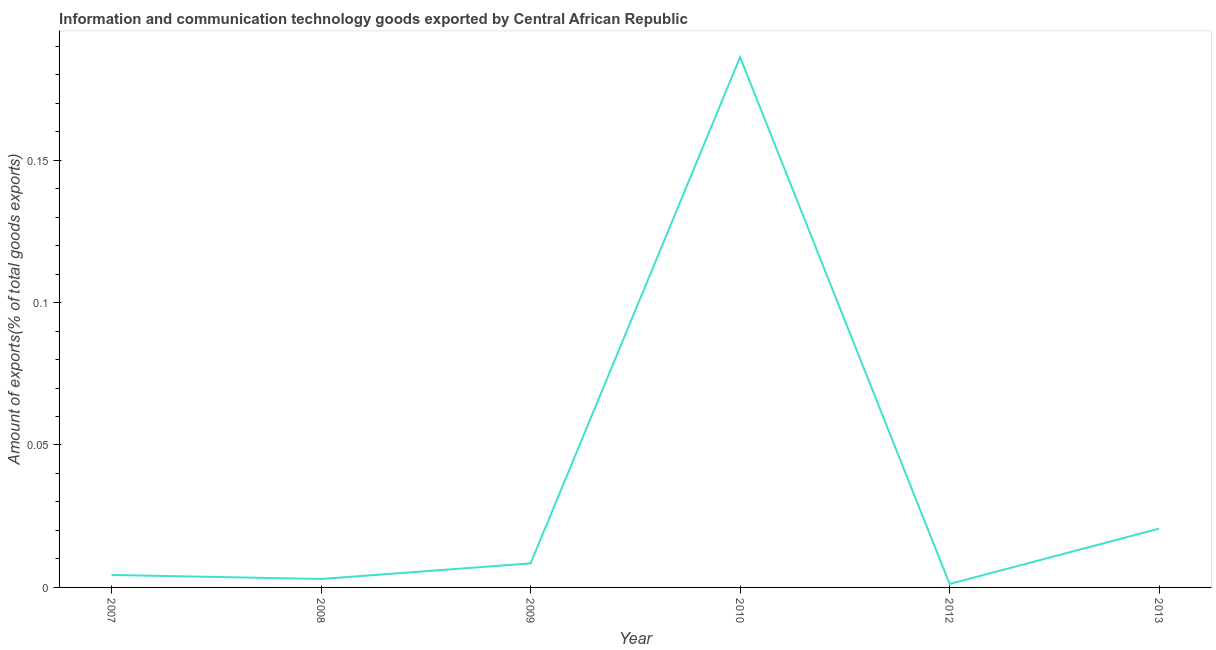What is the amount of ict goods exports in 2010?
Offer a very short reply. 0.19. Across all years, what is the maximum amount of ict goods exports?
Ensure brevity in your answer.  0.19. Across all years, what is the minimum amount of ict goods exports?
Ensure brevity in your answer.  0. In which year was the amount of ict goods exports maximum?
Give a very brief answer. 2010. In which year was the amount of ict goods exports minimum?
Make the answer very short. 2012. What is the sum of the amount of ict goods exports?
Provide a short and direct response. 0.22. What is the difference between the amount of ict goods exports in 2007 and 2008?
Your answer should be very brief. 0. What is the average amount of ict goods exports per year?
Provide a succinct answer. 0.04. What is the median amount of ict goods exports?
Give a very brief answer. 0.01. What is the ratio of the amount of ict goods exports in 2008 to that in 2013?
Ensure brevity in your answer.  0.14. Is the amount of ict goods exports in 2009 less than that in 2010?
Offer a very short reply. Yes. What is the difference between the highest and the second highest amount of ict goods exports?
Your response must be concise. 0.17. What is the difference between the highest and the lowest amount of ict goods exports?
Offer a very short reply. 0.18. In how many years, is the amount of ict goods exports greater than the average amount of ict goods exports taken over all years?
Provide a short and direct response. 1. How many lines are there?
Give a very brief answer. 1. What is the difference between two consecutive major ticks on the Y-axis?
Make the answer very short. 0.05. Are the values on the major ticks of Y-axis written in scientific E-notation?
Your answer should be very brief. No. Does the graph contain grids?
Your answer should be very brief. No. What is the title of the graph?
Provide a succinct answer. Information and communication technology goods exported by Central African Republic. What is the label or title of the X-axis?
Provide a succinct answer. Year. What is the label or title of the Y-axis?
Ensure brevity in your answer.  Amount of exports(% of total goods exports). What is the Amount of exports(% of total goods exports) of 2007?
Your answer should be compact. 0. What is the Amount of exports(% of total goods exports) of 2008?
Keep it short and to the point. 0. What is the Amount of exports(% of total goods exports) in 2009?
Ensure brevity in your answer.  0.01. What is the Amount of exports(% of total goods exports) in 2010?
Provide a succinct answer. 0.19. What is the Amount of exports(% of total goods exports) of 2012?
Keep it short and to the point. 0. What is the Amount of exports(% of total goods exports) in 2013?
Provide a succinct answer. 0.02. What is the difference between the Amount of exports(% of total goods exports) in 2007 and 2008?
Make the answer very short. 0. What is the difference between the Amount of exports(% of total goods exports) in 2007 and 2009?
Your response must be concise. -0. What is the difference between the Amount of exports(% of total goods exports) in 2007 and 2010?
Offer a very short reply. -0.18. What is the difference between the Amount of exports(% of total goods exports) in 2007 and 2012?
Offer a very short reply. 0. What is the difference between the Amount of exports(% of total goods exports) in 2007 and 2013?
Give a very brief answer. -0.02. What is the difference between the Amount of exports(% of total goods exports) in 2008 and 2009?
Offer a very short reply. -0.01. What is the difference between the Amount of exports(% of total goods exports) in 2008 and 2010?
Offer a terse response. -0.18. What is the difference between the Amount of exports(% of total goods exports) in 2008 and 2012?
Make the answer very short. 0. What is the difference between the Amount of exports(% of total goods exports) in 2008 and 2013?
Keep it short and to the point. -0.02. What is the difference between the Amount of exports(% of total goods exports) in 2009 and 2010?
Give a very brief answer. -0.18. What is the difference between the Amount of exports(% of total goods exports) in 2009 and 2012?
Your answer should be compact. 0.01. What is the difference between the Amount of exports(% of total goods exports) in 2009 and 2013?
Give a very brief answer. -0.01. What is the difference between the Amount of exports(% of total goods exports) in 2010 and 2012?
Make the answer very short. 0.18. What is the difference between the Amount of exports(% of total goods exports) in 2010 and 2013?
Offer a terse response. 0.17. What is the difference between the Amount of exports(% of total goods exports) in 2012 and 2013?
Provide a short and direct response. -0.02. What is the ratio of the Amount of exports(% of total goods exports) in 2007 to that in 2008?
Your answer should be compact. 1.48. What is the ratio of the Amount of exports(% of total goods exports) in 2007 to that in 2009?
Your answer should be compact. 0.52. What is the ratio of the Amount of exports(% of total goods exports) in 2007 to that in 2010?
Provide a succinct answer. 0.02. What is the ratio of the Amount of exports(% of total goods exports) in 2007 to that in 2012?
Ensure brevity in your answer.  3.61. What is the ratio of the Amount of exports(% of total goods exports) in 2007 to that in 2013?
Offer a very short reply. 0.21. What is the ratio of the Amount of exports(% of total goods exports) in 2008 to that in 2009?
Your answer should be very brief. 0.35. What is the ratio of the Amount of exports(% of total goods exports) in 2008 to that in 2010?
Offer a terse response. 0.02. What is the ratio of the Amount of exports(% of total goods exports) in 2008 to that in 2012?
Offer a terse response. 2.44. What is the ratio of the Amount of exports(% of total goods exports) in 2008 to that in 2013?
Give a very brief answer. 0.14. What is the ratio of the Amount of exports(% of total goods exports) in 2009 to that in 2010?
Keep it short and to the point. 0.04. What is the ratio of the Amount of exports(% of total goods exports) in 2009 to that in 2012?
Give a very brief answer. 6.96. What is the ratio of the Amount of exports(% of total goods exports) in 2009 to that in 2013?
Keep it short and to the point. 0.41. What is the ratio of the Amount of exports(% of total goods exports) in 2010 to that in 2012?
Keep it short and to the point. 153.56. What is the ratio of the Amount of exports(% of total goods exports) in 2010 to that in 2013?
Provide a short and direct response. 9.02. What is the ratio of the Amount of exports(% of total goods exports) in 2012 to that in 2013?
Ensure brevity in your answer.  0.06. 